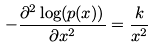Convert formula to latex. <formula><loc_0><loc_0><loc_500><loc_500>- \frac { \partial ^ { 2 } \log ( p ( x ) ) } { \partial x ^ { 2 } } = \frac { k } { x ^ { 2 } }</formula> 